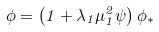Convert formula to latex. <formula><loc_0><loc_0><loc_500><loc_500>\phi = \left ( 1 + \lambda _ { 1 } \mu ^ { 2 } _ { 1 } \psi \right ) \phi _ { * }</formula> 